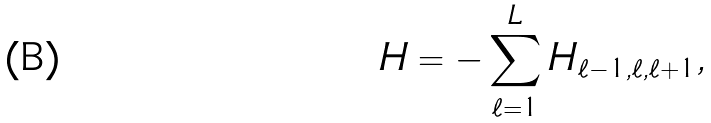<formula> <loc_0><loc_0><loc_500><loc_500>H = - \sum _ { \ell = 1 } ^ { L } H _ { \ell - 1 , \ell , \ell + 1 } ,</formula> 